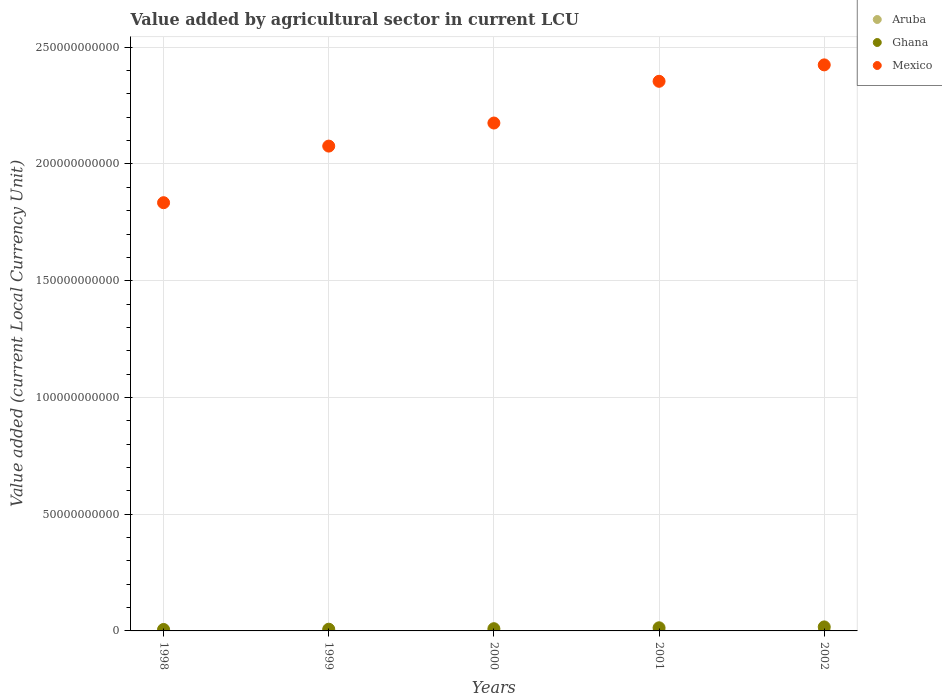How many different coloured dotlines are there?
Offer a terse response. 3. Is the number of dotlines equal to the number of legend labels?
Your answer should be compact. Yes. What is the value added by agricultural sector in Aruba in 1999?
Provide a short and direct response. 1.18e+07. Across all years, what is the maximum value added by agricultural sector in Mexico?
Your response must be concise. 2.42e+11. Across all years, what is the minimum value added by agricultural sector in Ghana?
Make the answer very short. 6.23e+08. What is the total value added by agricultural sector in Aruba in the graph?
Your response must be concise. 6.55e+07. What is the difference between the value added by agricultural sector in Aruba in 1999 and that in 2002?
Provide a succinct answer. -2.16e+06. What is the difference between the value added by agricultural sector in Mexico in 1999 and the value added by agricultural sector in Aruba in 2000?
Keep it short and to the point. 2.08e+11. What is the average value added by agricultural sector in Aruba per year?
Ensure brevity in your answer.  1.31e+07. In the year 1998, what is the difference between the value added by agricultural sector in Mexico and value added by agricultural sector in Ghana?
Give a very brief answer. 1.83e+11. What is the ratio of the value added by agricultural sector in Ghana in 1998 to that in 1999?
Your answer should be compact. 0.85. Is the value added by agricultural sector in Mexico in 2000 less than that in 2001?
Provide a succinct answer. Yes. What is the difference between the highest and the second highest value added by agricultural sector in Aruba?
Offer a terse response. 5.00e+04. What is the difference between the highest and the lowest value added by agricultural sector in Mexico?
Give a very brief answer. 5.90e+1. In how many years, is the value added by agricultural sector in Aruba greater than the average value added by agricultural sector in Aruba taken over all years?
Ensure brevity in your answer.  3. Is the sum of the value added by agricultural sector in Mexico in 2000 and 2001 greater than the maximum value added by agricultural sector in Aruba across all years?
Give a very brief answer. Yes. Is it the case that in every year, the sum of the value added by agricultural sector in Aruba and value added by agricultural sector in Ghana  is greater than the value added by agricultural sector in Mexico?
Provide a succinct answer. No. Does the value added by agricultural sector in Mexico monotonically increase over the years?
Provide a succinct answer. Yes. Is the value added by agricultural sector in Ghana strictly greater than the value added by agricultural sector in Mexico over the years?
Offer a very short reply. No. How many years are there in the graph?
Keep it short and to the point. 5. Does the graph contain grids?
Offer a terse response. Yes. Where does the legend appear in the graph?
Your response must be concise. Top right. How many legend labels are there?
Make the answer very short. 3. What is the title of the graph?
Your response must be concise. Value added by agricultural sector in current LCU. What is the label or title of the Y-axis?
Provide a short and direct response. Value added (current Local Currency Unit). What is the Value added (current Local Currency Unit) in Aruba in 1998?
Offer a very short reply. 1.20e+07. What is the Value added (current Local Currency Unit) of Ghana in 1998?
Make the answer very short. 6.23e+08. What is the Value added (current Local Currency Unit) of Mexico in 1998?
Offer a very short reply. 1.83e+11. What is the Value added (current Local Currency Unit) of Aruba in 1999?
Your response must be concise. 1.18e+07. What is the Value added (current Local Currency Unit) of Ghana in 1999?
Give a very brief answer. 7.36e+08. What is the Value added (current Local Currency Unit) in Mexico in 1999?
Make the answer very short. 2.08e+11. What is the Value added (current Local Currency Unit) of Aruba in 2000?
Offer a terse response. 1.38e+07. What is the Value added (current Local Currency Unit) of Ghana in 2000?
Offer a very short reply. 9.58e+08. What is the Value added (current Local Currency Unit) of Mexico in 2000?
Make the answer very short. 2.18e+11. What is the Value added (current Local Currency Unit) of Aruba in 2001?
Keep it short and to the point. 1.39e+07. What is the Value added (current Local Currency Unit) of Ghana in 2001?
Offer a terse response. 1.34e+09. What is the Value added (current Local Currency Unit) of Mexico in 2001?
Keep it short and to the point. 2.35e+11. What is the Value added (current Local Currency Unit) in Aruba in 2002?
Provide a succinct answer. 1.40e+07. What is the Value added (current Local Currency Unit) in Ghana in 2002?
Give a very brief answer. 1.72e+09. What is the Value added (current Local Currency Unit) of Mexico in 2002?
Offer a terse response. 2.42e+11. Across all years, what is the maximum Value added (current Local Currency Unit) of Aruba?
Your answer should be very brief. 1.40e+07. Across all years, what is the maximum Value added (current Local Currency Unit) in Ghana?
Keep it short and to the point. 1.72e+09. Across all years, what is the maximum Value added (current Local Currency Unit) in Mexico?
Offer a very short reply. 2.42e+11. Across all years, what is the minimum Value added (current Local Currency Unit) in Aruba?
Provide a succinct answer. 1.18e+07. Across all years, what is the minimum Value added (current Local Currency Unit) of Ghana?
Your response must be concise. 6.23e+08. Across all years, what is the minimum Value added (current Local Currency Unit) in Mexico?
Your response must be concise. 1.83e+11. What is the total Value added (current Local Currency Unit) of Aruba in the graph?
Offer a very short reply. 6.55e+07. What is the total Value added (current Local Currency Unit) of Ghana in the graph?
Make the answer very short. 5.38e+09. What is the total Value added (current Local Currency Unit) of Mexico in the graph?
Ensure brevity in your answer.  1.09e+12. What is the difference between the Value added (current Local Currency Unit) in Aruba in 1998 and that in 1999?
Your answer should be very brief. 1.80e+05. What is the difference between the Value added (current Local Currency Unit) in Ghana in 1998 and that in 1999?
Provide a short and direct response. -1.13e+08. What is the difference between the Value added (current Local Currency Unit) of Mexico in 1998 and that in 1999?
Provide a short and direct response. -2.42e+1. What is the difference between the Value added (current Local Currency Unit) in Aruba in 1998 and that in 2000?
Provide a short and direct response. -1.75e+06. What is the difference between the Value added (current Local Currency Unit) of Ghana in 1998 and that in 2000?
Provide a succinct answer. -3.35e+08. What is the difference between the Value added (current Local Currency Unit) in Mexico in 1998 and that in 2000?
Your answer should be very brief. -3.41e+1. What is the difference between the Value added (current Local Currency Unit) of Aruba in 1998 and that in 2001?
Your answer should be very brief. -1.93e+06. What is the difference between the Value added (current Local Currency Unit) in Ghana in 1998 and that in 2001?
Make the answer very short. -7.19e+08. What is the difference between the Value added (current Local Currency Unit) of Mexico in 1998 and that in 2001?
Offer a terse response. -5.20e+1. What is the difference between the Value added (current Local Currency Unit) of Aruba in 1998 and that in 2002?
Keep it short and to the point. -1.98e+06. What is the difference between the Value added (current Local Currency Unit) in Ghana in 1998 and that in 2002?
Keep it short and to the point. -1.09e+09. What is the difference between the Value added (current Local Currency Unit) of Mexico in 1998 and that in 2002?
Offer a terse response. -5.90e+1. What is the difference between the Value added (current Local Currency Unit) of Aruba in 1999 and that in 2000?
Keep it short and to the point. -1.93e+06. What is the difference between the Value added (current Local Currency Unit) of Ghana in 1999 and that in 2000?
Provide a short and direct response. -2.21e+08. What is the difference between the Value added (current Local Currency Unit) in Mexico in 1999 and that in 2000?
Make the answer very short. -9.88e+09. What is the difference between the Value added (current Local Currency Unit) of Aruba in 1999 and that in 2001?
Offer a very short reply. -2.11e+06. What is the difference between the Value added (current Local Currency Unit) in Ghana in 1999 and that in 2001?
Ensure brevity in your answer.  -6.05e+08. What is the difference between the Value added (current Local Currency Unit) in Mexico in 1999 and that in 2001?
Provide a succinct answer. -2.78e+1. What is the difference between the Value added (current Local Currency Unit) of Aruba in 1999 and that in 2002?
Provide a succinct answer. -2.16e+06. What is the difference between the Value added (current Local Currency Unit) in Ghana in 1999 and that in 2002?
Make the answer very short. -9.81e+08. What is the difference between the Value added (current Local Currency Unit) in Mexico in 1999 and that in 2002?
Offer a very short reply. -3.48e+1. What is the difference between the Value added (current Local Currency Unit) in Aruba in 2000 and that in 2001?
Your answer should be very brief. -1.80e+05. What is the difference between the Value added (current Local Currency Unit) of Ghana in 2000 and that in 2001?
Offer a terse response. -3.84e+08. What is the difference between the Value added (current Local Currency Unit) of Mexico in 2000 and that in 2001?
Give a very brief answer. -1.79e+1. What is the difference between the Value added (current Local Currency Unit) in Aruba in 2000 and that in 2002?
Offer a terse response. -2.30e+05. What is the difference between the Value added (current Local Currency Unit) of Ghana in 2000 and that in 2002?
Give a very brief answer. -7.60e+08. What is the difference between the Value added (current Local Currency Unit) in Mexico in 2000 and that in 2002?
Your response must be concise. -2.49e+1. What is the difference between the Value added (current Local Currency Unit) of Aruba in 2001 and that in 2002?
Provide a short and direct response. -5.00e+04. What is the difference between the Value added (current Local Currency Unit) of Ghana in 2001 and that in 2002?
Provide a succinct answer. -3.76e+08. What is the difference between the Value added (current Local Currency Unit) in Mexico in 2001 and that in 2002?
Provide a succinct answer. -7.03e+09. What is the difference between the Value added (current Local Currency Unit) in Aruba in 1998 and the Value added (current Local Currency Unit) in Ghana in 1999?
Make the answer very short. -7.24e+08. What is the difference between the Value added (current Local Currency Unit) of Aruba in 1998 and the Value added (current Local Currency Unit) of Mexico in 1999?
Offer a very short reply. -2.08e+11. What is the difference between the Value added (current Local Currency Unit) in Ghana in 1998 and the Value added (current Local Currency Unit) in Mexico in 1999?
Give a very brief answer. -2.07e+11. What is the difference between the Value added (current Local Currency Unit) of Aruba in 1998 and the Value added (current Local Currency Unit) of Ghana in 2000?
Offer a terse response. -9.46e+08. What is the difference between the Value added (current Local Currency Unit) in Aruba in 1998 and the Value added (current Local Currency Unit) in Mexico in 2000?
Offer a terse response. -2.18e+11. What is the difference between the Value added (current Local Currency Unit) in Ghana in 1998 and the Value added (current Local Currency Unit) in Mexico in 2000?
Make the answer very short. -2.17e+11. What is the difference between the Value added (current Local Currency Unit) of Aruba in 1998 and the Value added (current Local Currency Unit) of Ghana in 2001?
Make the answer very short. -1.33e+09. What is the difference between the Value added (current Local Currency Unit) of Aruba in 1998 and the Value added (current Local Currency Unit) of Mexico in 2001?
Give a very brief answer. -2.35e+11. What is the difference between the Value added (current Local Currency Unit) of Ghana in 1998 and the Value added (current Local Currency Unit) of Mexico in 2001?
Your answer should be very brief. -2.35e+11. What is the difference between the Value added (current Local Currency Unit) in Aruba in 1998 and the Value added (current Local Currency Unit) in Ghana in 2002?
Give a very brief answer. -1.71e+09. What is the difference between the Value added (current Local Currency Unit) in Aruba in 1998 and the Value added (current Local Currency Unit) in Mexico in 2002?
Your response must be concise. -2.42e+11. What is the difference between the Value added (current Local Currency Unit) in Ghana in 1998 and the Value added (current Local Currency Unit) in Mexico in 2002?
Keep it short and to the point. -2.42e+11. What is the difference between the Value added (current Local Currency Unit) in Aruba in 1999 and the Value added (current Local Currency Unit) in Ghana in 2000?
Offer a terse response. -9.46e+08. What is the difference between the Value added (current Local Currency Unit) in Aruba in 1999 and the Value added (current Local Currency Unit) in Mexico in 2000?
Provide a succinct answer. -2.18e+11. What is the difference between the Value added (current Local Currency Unit) in Ghana in 1999 and the Value added (current Local Currency Unit) in Mexico in 2000?
Make the answer very short. -2.17e+11. What is the difference between the Value added (current Local Currency Unit) of Aruba in 1999 and the Value added (current Local Currency Unit) of Ghana in 2001?
Give a very brief answer. -1.33e+09. What is the difference between the Value added (current Local Currency Unit) in Aruba in 1999 and the Value added (current Local Currency Unit) in Mexico in 2001?
Your answer should be very brief. -2.35e+11. What is the difference between the Value added (current Local Currency Unit) of Ghana in 1999 and the Value added (current Local Currency Unit) of Mexico in 2001?
Your response must be concise. -2.35e+11. What is the difference between the Value added (current Local Currency Unit) of Aruba in 1999 and the Value added (current Local Currency Unit) of Ghana in 2002?
Make the answer very short. -1.71e+09. What is the difference between the Value added (current Local Currency Unit) of Aruba in 1999 and the Value added (current Local Currency Unit) of Mexico in 2002?
Keep it short and to the point. -2.42e+11. What is the difference between the Value added (current Local Currency Unit) in Ghana in 1999 and the Value added (current Local Currency Unit) in Mexico in 2002?
Offer a terse response. -2.42e+11. What is the difference between the Value added (current Local Currency Unit) of Aruba in 2000 and the Value added (current Local Currency Unit) of Ghana in 2001?
Keep it short and to the point. -1.33e+09. What is the difference between the Value added (current Local Currency Unit) of Aruba in 2000 and the Value added (current Local Currency Unit) of Mexico in 2001?
Give a very brief answer. -2.35e+11. What is the difference between the Value added (current Local Currency Unit) in Ghana in 2000 and the Value added (current Local Currency Unit) in Mexico in 2001?
Provide a succinct answer. -2.34e+11. What is the difference between the Value added (current Local Currency Unit) in Aruba in 2000 and the Value added (current Local Currency Unit) in Ghana in 2002?
Offer a very short reply. -1.70e+09. What is the difference between the Value added (current Local Currency Unit) of Aruba in 2000 and the Value added (current Local Currency Unit) of Mexico in 2002?
Offer a very short reply. -2.42e+11. What is the difference between the Value added (current Local Currency Unit) in Ghana in 2000 and the Value added (current Local Currency Unit) in Mexico in 2002?
Provide a succinct answer. -2.41e+11. What is the difference between the Value added (current Local Currency Unit) of Aruba in 2001 and the Value added (current Local Currency Unit) of Ghana in 2002?
Provide a short and direct response. -1.70e+09. What is the difference between the Value added (current Local Currency Unit) of Aruba in 2001 and the Value added (current Local Currency Unit) of Mexico in 2002?
Provide a succinct answer. -2.42e+11. What is the difference between the Value added (current Local Currency Unit) of Ghana in 2001 and the Value added (current Local Currency Unit) of Mexico in 2002?
Provide a succinct answer. -2.41e+11. What is the average Value added (current Local Currency Unit) of Aruba per year?
Ensure brevity in your answer.  1.31e+07. What is the average Value added (current Local Currency Unit) in Ghana per year?
Provide a succinct answer. 1.08e+09. What is the average Value added (current Local Currency Unit) in Mexico per year?
Provide a succinct answer. 2.17e+11. In the year 1998, what is the difference between the Value added (current Local Currency Unit) of Aruba and Value added (current Local Currency Unit) of Ghana?
Provide a short and direct response. -6.11e+08. In the year 1998, what is the difference between the Value added (current Local Currency Unit) of Aruba and Value added (current Local Currency Unit) of Mexico?
Provide a short and direct response. -1.83e+11. In the year 1998, what is the difference between the Value added (current Local Currency Unit) in Ghana and Value added (current Local Currency Unit) in Mexico?
Keep it short and to the point. -1.83e+11. In the year 1999, what is the difference between the Value added (current Local Currency Unit) of Aruba and Value added (current Local Currency Unit) of Ghana?
Ensure brevity in your answer.  -7.24e+08. In the year 1999, what is the difference between the Value added (current Local Currency Unit) in Aruba and Value added (current Local Currency Unit) in Mexico?
Offer a very short reply. -2.08e+11. In the year 1999, what is the difference between the Value added (current Local Currency Unit) of Ghana and Value added (current Local Currency Unit) of Mexico?
Your answer should be very brief. -2.07e+11. In the year 2000, what is the difference between the Value added (current Local Currency Unit) in Aruba and Value added (current Local Currency Unit) in Ghana?
Your answer should be compact. -9.44e+08. In the year 2000, what is the difference between the Value added (current Local Currency Unit) in Aruba and Value added (current Local Currency Unit) in Mexico?
Keep it short and to the point. -2.18e+11. In the year 2000, what is the difference between the Value added (current Local Currency Unit) of Ghana and Value added (current Local Currency Unit) of Mexico?
Keep it short and to the point. -2.17e+11. In the year 2001, what is the difference between the Value added (current Local Currency Unit) of Aruba and Value added (current Local Currency Unit) of Ghana?
Give a very brief answer. -1.33e+09. In the year 2001, what is the difference between the Value added (current Local Currency Unit) of Aruba and Value added (current Local Currency Unit) of Mexico?
Ensure brevity in your answer.  -2.35e+11. In the year 2001, what is the difference between the Value added (current Local Currency Unit) of Ghana and Value added (current Local Currency Unit) of Mexico?
Provide a short and direct response. -2.34e+11. In the year 2002, what is the difference between the Value added (current Local Currency Unit) in Aruba and Value added (current Local Currency Unit) in Ghana?
Provide a succinct answer. -1.70e+09. In the year 2002, what is the difference between the Value added (current Local Currency Unit) of Aruba and Value added (current Local Currency Unit) of Mexico?
Your response must be concise. -2.42e+11. In the year 2002, what is the difference between the Value added (current Local Currency Unit) in Ghana and Value added (current Local Currency Unit) in Mexico?
Give a very brief answer. -2.41e+11. What is the ratio of the Value added (current Local Currency Unit) of Aruba in 1998 to that in 1999?
Keep it short and to the point. 1.02. What is the ratio of the Value added (current Local Currency Unit) in Ghana in 1998 to that in 1999?
Offer a very short reply. 0.85. What is the ratio of the Value added (current Local Currency Unit) of Mexico in 1998 to that in 1999?
Make the answer very short. 0.88. What is the ratio of the Value added (current Local Currency Unit) in Aruba in 1998 to that in 2000?
Keep it short and to the point. 0.87. What is the ratio of the Value added (current Local Currency Unit) in Ghana in 1998 to that in 2000?
Provide a short and direct response. 0.65. What is the ratio of the Value added (current Local Currency Unit) in Mexico in 1998 to that in 2000?
Keep it short and to the point. 0.84. What is the ratio of the Value added (current Local Currency Unit) of Aruba in 1998 to that in 2001?
Your response must be concise. 0.86. What is the ratio of the Value added (current Local Currency Unit) of Ghana in 1998 to that in 2001?
Offer a very short reply. 0.46. What is the ratio of the Value added (current Local Currency Unit) of Mexico in 1998 to that in 2001?
Your response must be concise. 0.78. What is the ratio of the Value added (current Local Currency Unit) in Aruba in 1998 to that in 2002?
Ensure brevity in your answer.  0.86. What is the ratio of the Value added (current Local Currency Unit) in Ghana in 1998 to that in 2002?
Your response must be concise. 0.36. What is the ratio of the Value added (current Local Currency Unit) in Mexico in 1998 to that in 2002?
Provide a succinct answer. 0.76. What is the ratio of the Value added (current Local Currency Unit) of Aruba in 1999 to that in 2000?
Your response must be concise. 0.86. What is the ratio of the Value added (current Local Currency Unit) in Ghana in 1999 to that in 2000?
Offer a terse response. 0.77. What is the ratio of the Value added (current Local Currency Unit) of Mexico in 1999 to that in 2000?
Make the answer very short. 0.95. What is the ratio of the Value added (current Local Currency Unit) in Aruba in 1999 to that in 2001?
Offer a terse response. 0.85. What is the ratio of the Value added (current Local Currency Unit) in Ghana in 1999 to that in 2001?
Offer a very short reply. 0.55. What is the ratio of the Value added (current Local Currency Unit) of Mexico in 1999 to that in 2001?
Provide a succinct answer. 0.88. What is the ratio of the Value added (current Local Currency Unit) of Aruba in 1999 to that in 2002?
Provide a short and direct response. 0.85. What is the ratio of the Value added (current Local Currency Unit) of Ghana in 1999 to that in 2002?
Your response must be concise. 0.43. What is the ratio of the Value added (current Local Currency Unit) in Mexico in 1999 to that in 2002?
Your answer should be very brief. 0.86. What is the ratio of the Value added (current Local Currency Unit) in Aruba in 2000 to that in 2001?
Keep it short and to the point. 0.99. What is the ratio of the Value added (current Local Currency Unit) in Ghana in 2000 to that in 2001?
Your answer should be compact. 0.71. What is the ratio of the Value added (current Local Currency Unit) of Mexico in 2000 to that in 2001?
Offer a very short reply. 0.92. What is the ratio of the Value added (current Local Currency Unit) of Aruba in 2000 to that in 2002?
Ensure brevity in your answer.  0.98. What is the ratio of the Value added (current Local Currency Unit) of Ghana in 2000 to that in 2002?
Offer a very short reply. 0.56. What is the ratio of the Value added (current Local Currency Unit) in Mexico in 2000 to that in 2002?
Offer a terse response. 0.9. What is the ratio of the Value added (current Local Currency Unit) in Aruba in 2001 to that in 2002?
Your answer should be very brief. 1. What is the ratio of the Value added (current Local Currency Unit) of Ghana in 2001 to that in 2002?
Keep it short and to the point. 0.78. What is the difference between the highest and the second highest Value added (current Local Currency Unit) of Ghana?
Make the answer very short. 3.76e+08. What is the difference between the highest and the second highest Value added (current Local Currency Unit) of Mexico?
Offer a very short reply. 7.03e+09. What is the difference between the highest and the lowest Value added (current Local Currency Unit) in Aruba?
Offer a very short reply. 2.16e+06. What is the difference between the highest and the lowest Value added (current Local Currency Unit) of Ghana?
Make the answer very short. 1.09e+09. What is the difference between the highest and the lowest Value added (current Local Currency Unit) in Mexico?
Ensure brevity in your answer.  5.90e+1. 